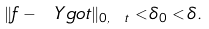Convert formula to latex. <formula><loc_0><loc_0><loc_500><loc_500>\| f - \ Y g o t \| _ { 0 , \ t } < \delta _ { 0 } < \delta .</formula> 